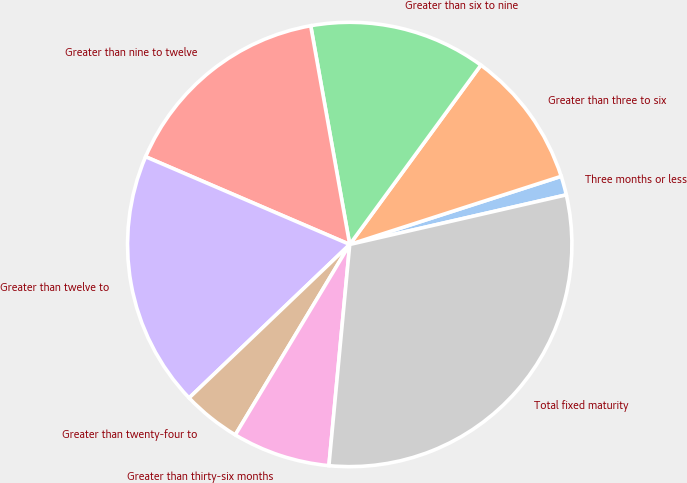Convert chart to OTSL. <chart><loc_0><loc_0><loc_500><loc_500><pie_chart><fcel>Three months or less<fcel>Greater than three to six<fcel>Greater than six to nine<fcel>Greater than nine to twelve<fcel>Greater than twelve to<fcel>Greater than twenty-four to<fcel>Greater than thirty-six months<fcel>Total fixed maturity<nl><fcel>1.38%<fcel>9.99%<fcel>12.86%<fcel>15.73%<fcel>18.6%<fcel>4.25%<fcel>7.12%<fcel>30.08%<nl></chart> 